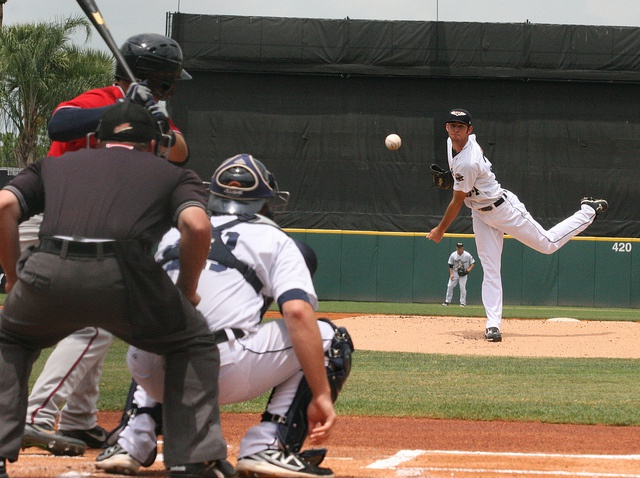Describe the objects in this image and their specific colors. I can see people in black, gray, and maroon tones, people in black, lavender, gray, and darkgray tones, people in black, lavender, and darkgray tones, people in black, gray, maroon, and red tones, and baseball bat in black, gray, darkgray, and khaki tones in this image. 